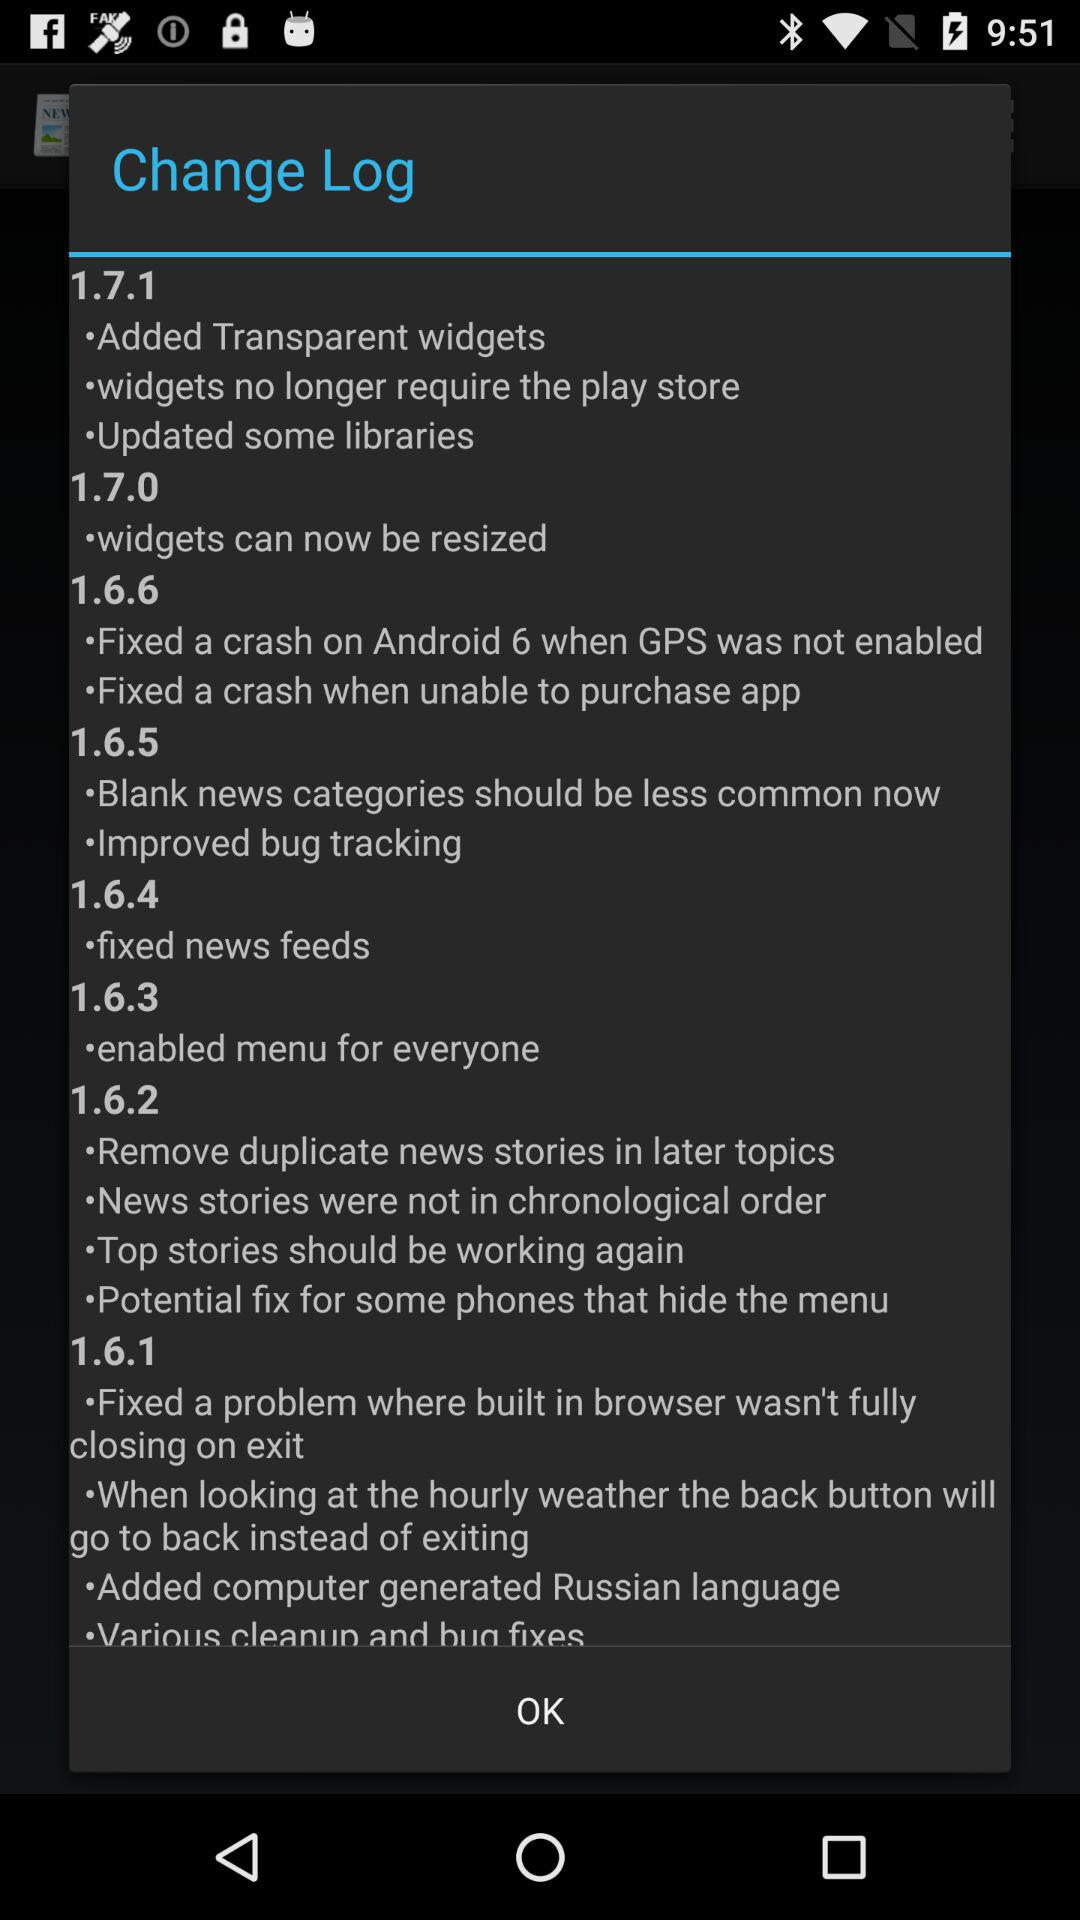What is the change in version 1.6.5? The changes are "Blank news categories should be less common now" and "Improved bug tracking". 